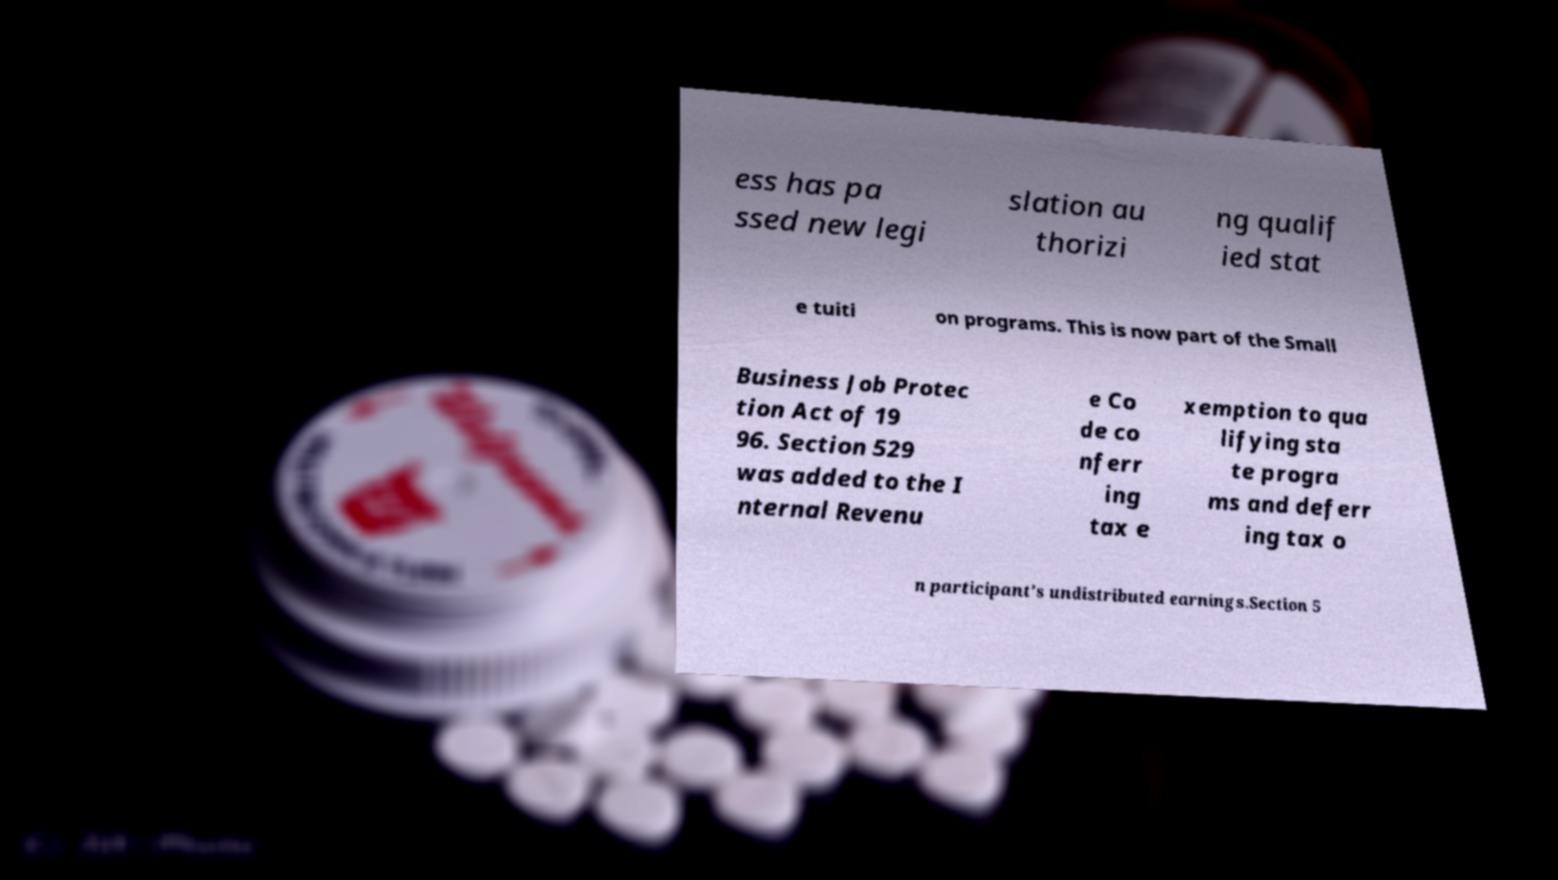I need the written content from this picture converted into text. Can you do that? ess has pa ssed new legi slation au thorizi ng qualif ied stat e tuiti on programs. This is now part of the Small Business Job Protec tion Act of 19 96. Section 529 was added to the I nternal Revenu e Co de co nferr ing tax e xemption to qua lifying sta te progra ms and deferr ing tax o n participant's undistributed earnings.Section 5 